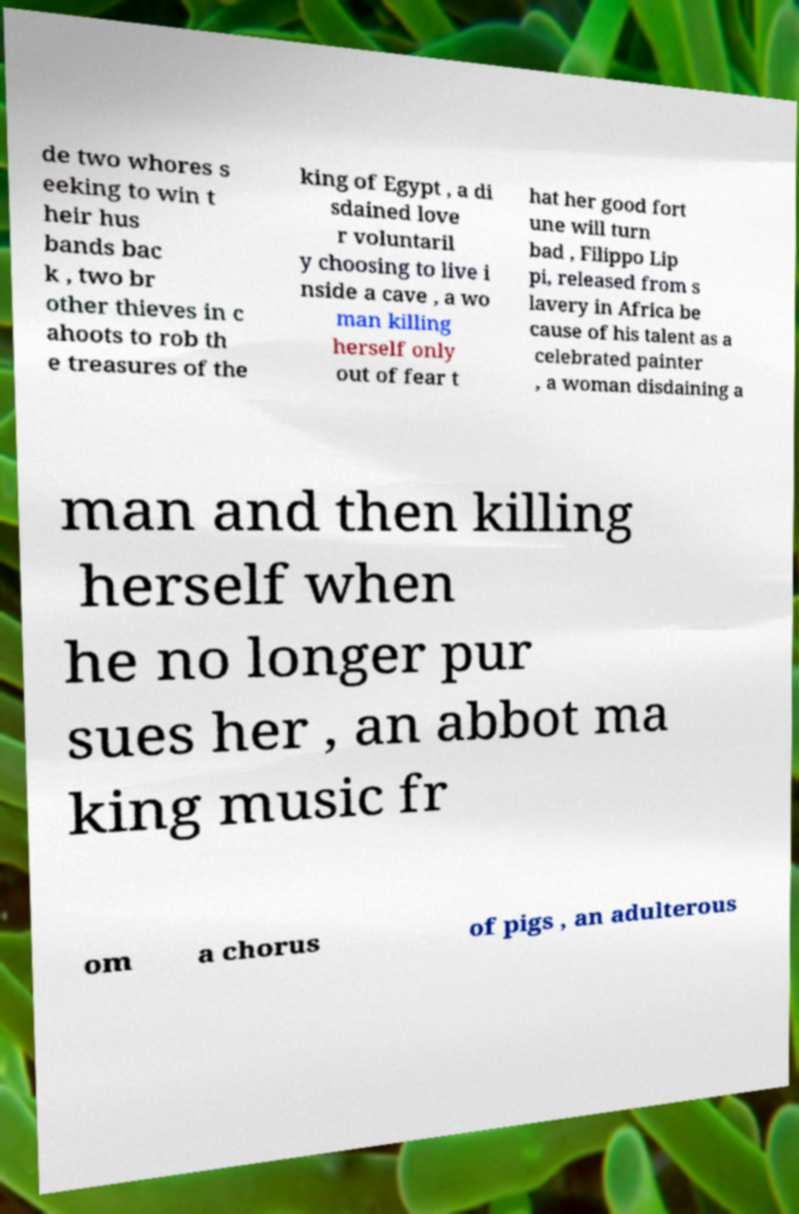I need the written content from this picture converted into text. Can you do that? de two whores s eeking to win t heir hus bands bac k , two br other thieves in c ahoots to rob th e treasures of the king of Egypt , a di sdained love r voluntaril y choosing to live i nside a cave , a wo man killing herself only out of fear t hat her good fort une will turn bad , Filippo Lip pi, released from s lavery in Africa be cause of his talent as a celebrated painter , a woman disdaining a man and then killing herself when he no longer pur sues her , an abbot ma king music fr om a chorus of pigs , an adulterous 